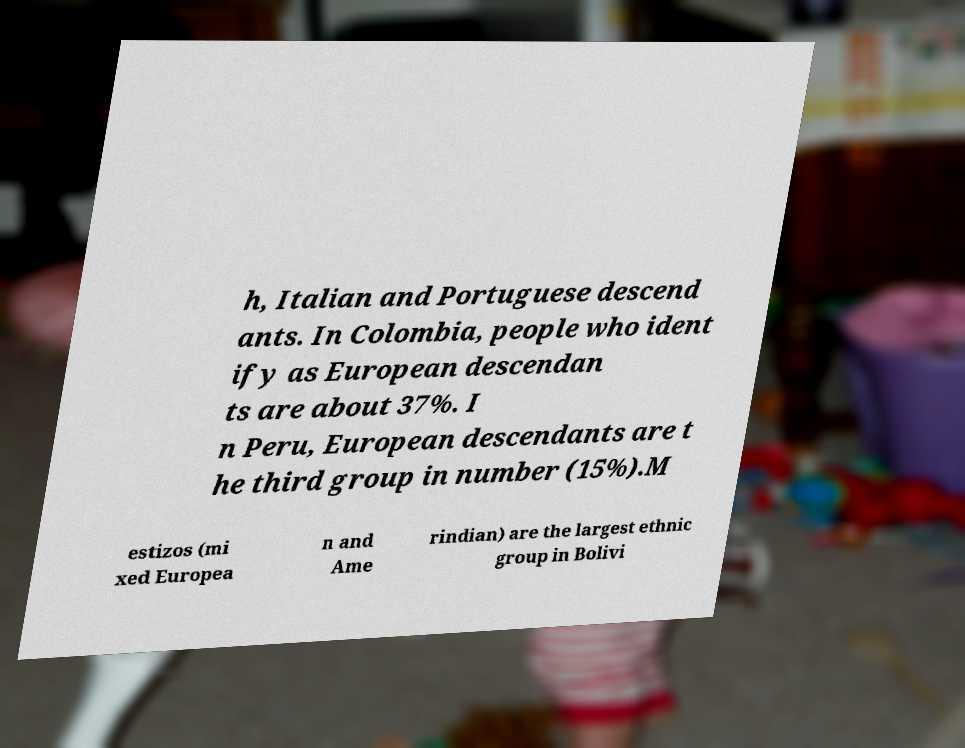Please read and relay the text visible in this image. What does it say? h, Italian and Portuguese descend ants. In Colombia, people who ident ify as European descendan ts are about 37%. I n Peru, European descendants are t he third group in number (15%).M estizos (mi xed Europea n and Ame rindian) are the largest ethnic group in Bolivi 